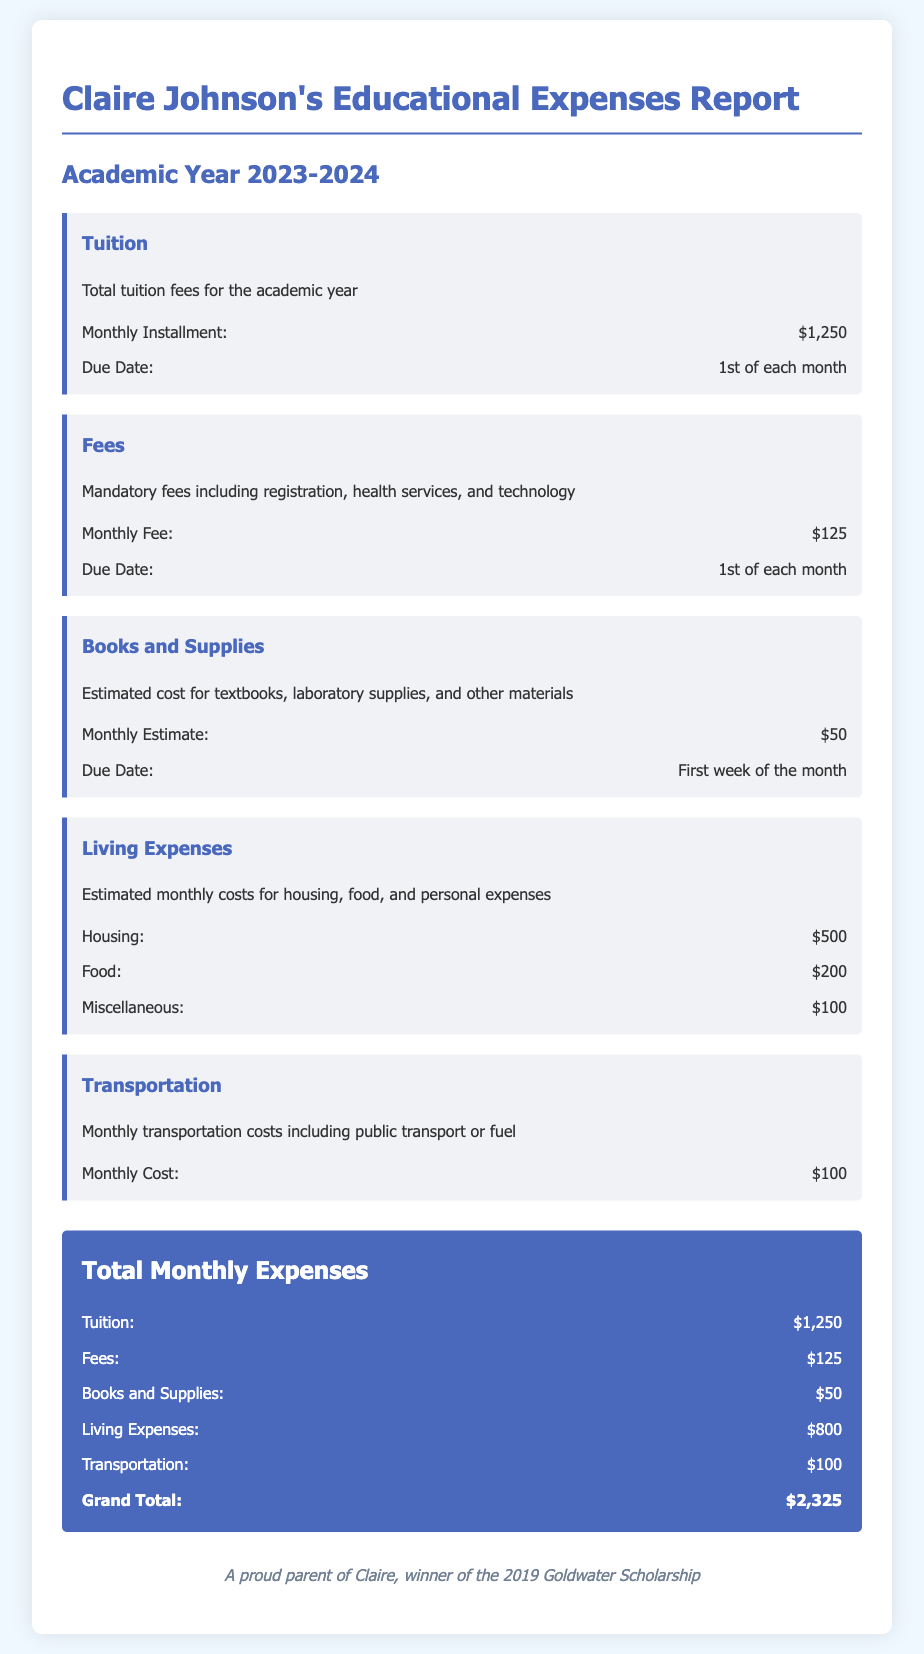what is the total tuition fee for the academic year? The total tuition fee for the academic year is stated as a monthly installment multiplied by the number of months, which is $1,250.
Answer: $1,250 what are the mandatory fees included? Mandatory fees include registration, health services, and technology as detailed in the document.
Answer: Registration, health services, and technology how much is the estimated monthly cost for books and supplies? The document specifies the estimated monthly cost for books and supplies.
Answer: $50 what is the total amount for living expenses per month? The living expenses add up to housing, food, and miscellaneous costs, which total $800 per month.
Answer: $800 when is the tuition payment due? The document specifies the due date for tuition payments.
Answer: 1st of each month what is the grand total of monthly expenses? The total monthly expenses are calculated by summing all the expense categories stated in the report.
Answer: $2,325 which category has the highest expense? The question asks for identifying the category with the highest expense mentioned in the report.
Answer: Tuition how much is allocated for transportation per month? The document provides a specific amount allocated for transportation each month.
Answer: $100 what is the purpose of this document? The document serves to outline Claire's educational expenses for the academic year.
Answer: Educational expenses report 